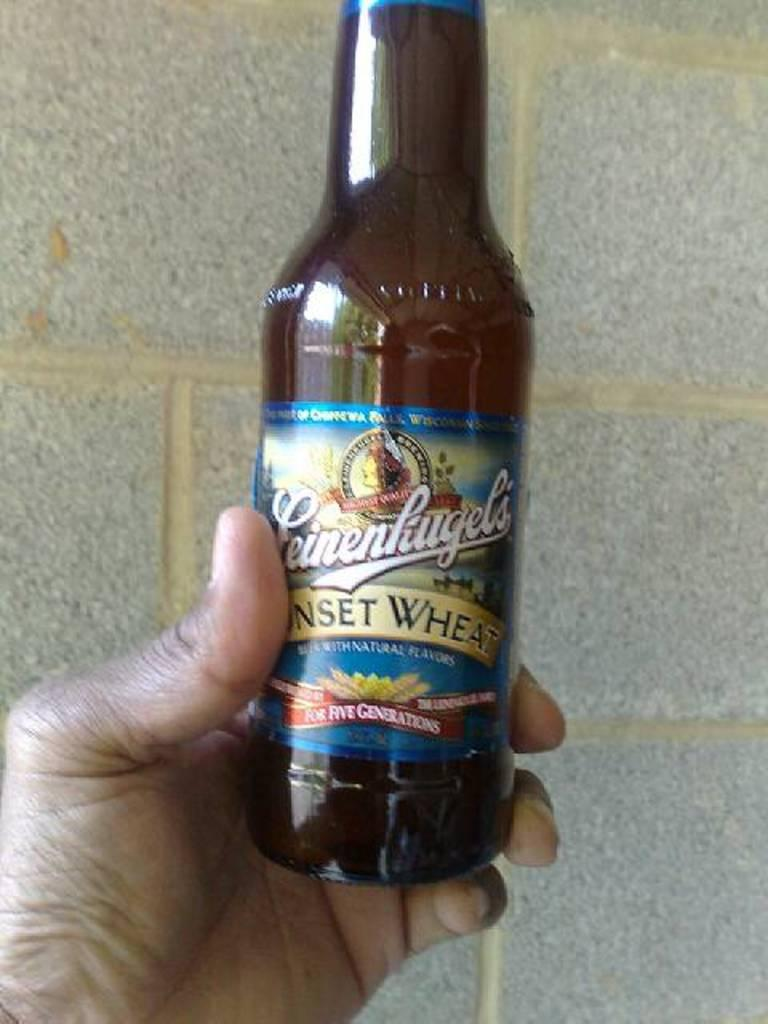<image>
Relay a brief, clear account of the picture shown. Person holding a bottle of Leinenliugel's with a blue label. 